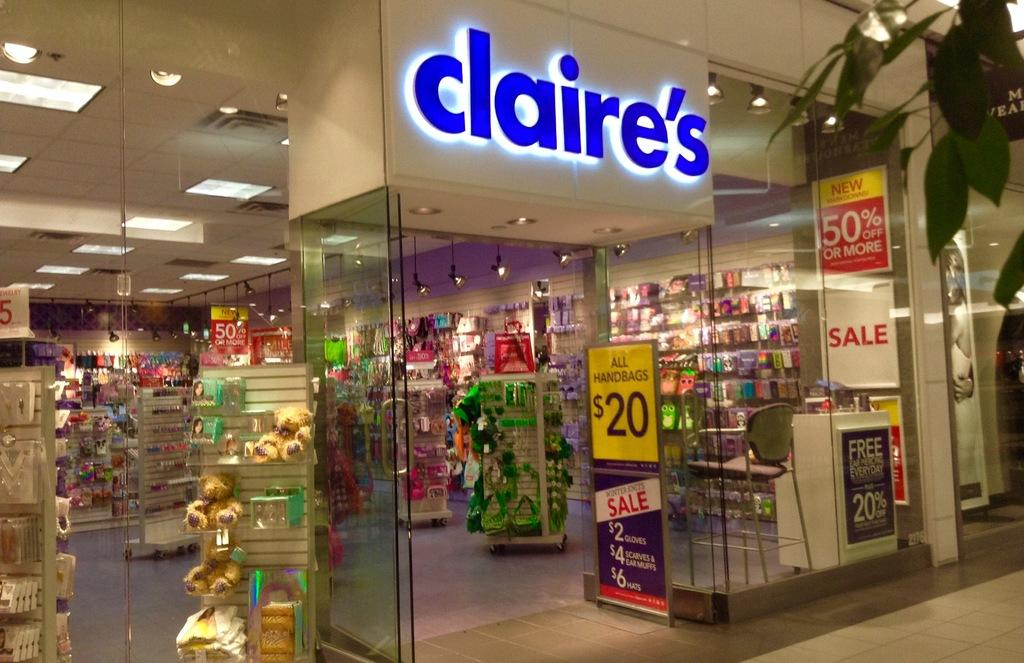<image>
Present a compact description of the photo's key features. A Claire's store says they are having a sale where all handbags are $20. 